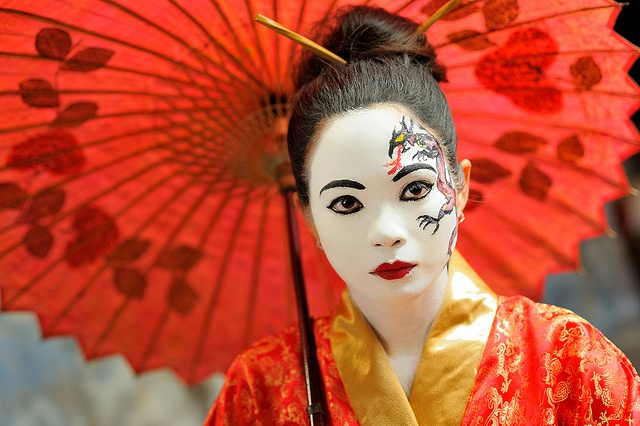Describe the objects in this image and their specific colors. I can see umbrella in red, brown, and salmon tones and people in red, ivory, and tan tones in this image. 